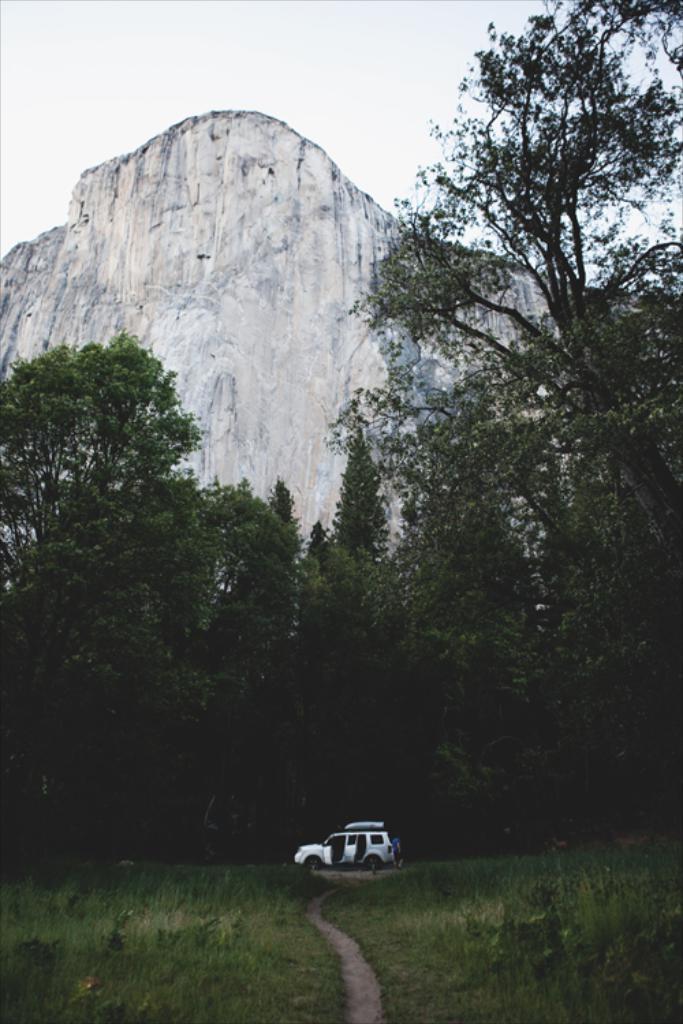How would you summarize this image in a sentence or two? This picture is clicked outside. In the center we can see a car seems to be parked on the ground and we can see the green grass, trees and rocks. In the background we can see the sky. 